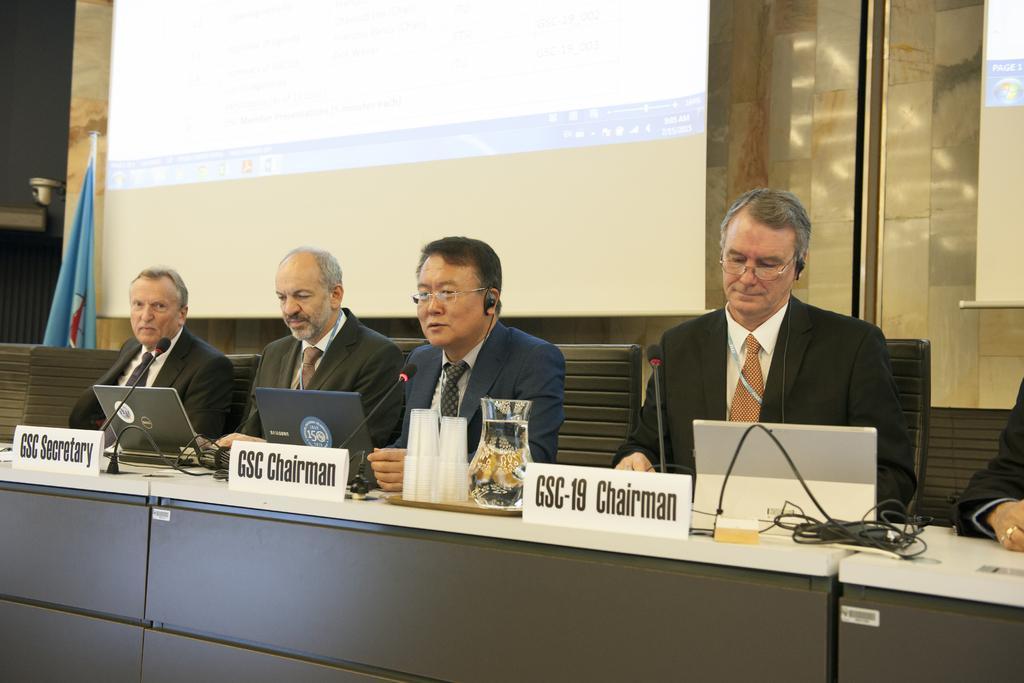Please provide a concise description of this image. In this image I can see four men are sitting on chairs. I can see all of them are wearing formal dress. In the front of them I can see few tables, three white colour boards, few laptops, a plate, a jar, number of glasses, few mice and few wires. I can also see something is written on these boards. In the background I can see two projectors screens, a flag and on these screens I can see something is written. 